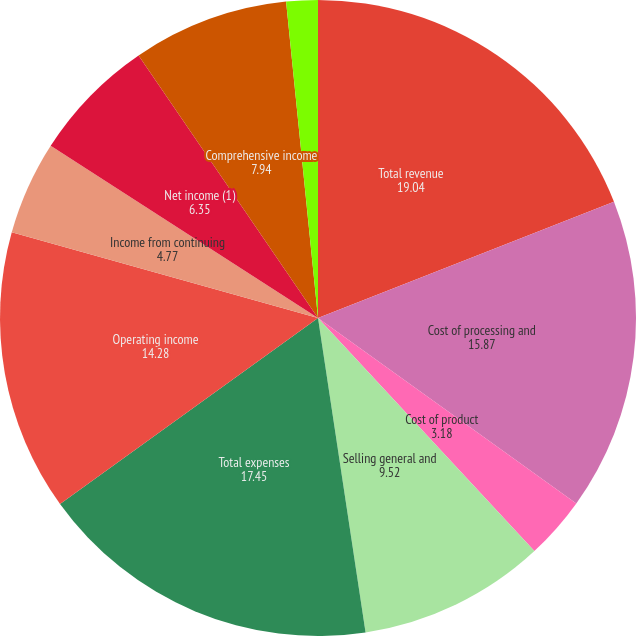Convert chart to OTSL. <chart><loc_0><loc_0><loc_500><loc_500><pie_chart><fcel>Total revenue<fcel>Cost of processing and<fcel>Cost of product<fcel>Selling general and<fcel>Total expenses<fcel>Operating income<fcel>Income from continuing<fcel>Net income (1)<fcel>Comprehensive income<fcel>Basic<nl><fcel>19.04%<fcel>15.87%<fcel>3.18%<fcel>9.52%<fcel>17.45%<fcel>14.28%<fcel>4.77%<fcel>6.35%<fcel>7.94%<fcel>1.6%<nl></chart> 